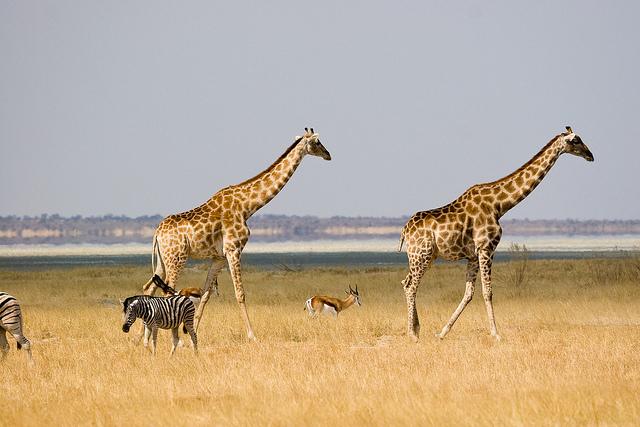What type of environment is this?
Concise answer only. Plains. Is there a zebra in the picture?
Answer briefly. Yes. Does it appear water is nearby?
Concise answer only. Yes. What is the tallest species of animal?
Write a very short answer. Giraffe. 